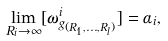<formula> <loc_0><loc_0><loc_500><loc_500>\lim _ { R _ { i } \to \infty } [ \omega ^ { i } _ { g _ { ( R _ { 1 } , \dots , R _ { l } ) } } ] = \alpha _ { i } ,</formula> 